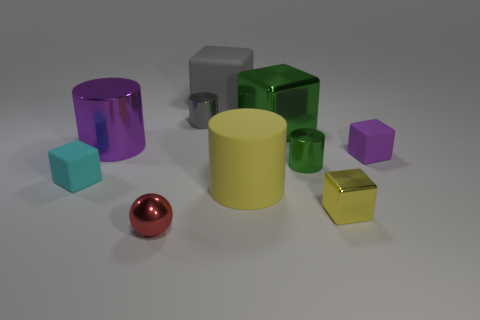There is a matte block that is the same color as the large metal cylinder; what size is it?
Ensure brevity in your answer.  Small. Is there a small purple thing made of the same material as the tiny purple cube?
Offer a terse response. No. There is a shiny thing that is left of the gray metal cylinder and behind the matte cylinder; what color is it?
Offer a very short reply. Purple. What is the material of the gray object to the left of the large matte block?
Provide a short and direct response. Metal. Are there any other metal objects that have the same shape as the big yellow object?
Offer a terse response. Yes. What number of other things are there of the same shape as the small gray metal object?
Your answer should be compact. 3. There is a red object; is it the same shape as the tiny thing that is behind the big purple cylinder?
Ensure brevity in your answer.  No. Are there any other things that have the same material as the tiny green thing?
Offer a terse response. Yes. What is the material of the tiny cyan thing that is the same shape as the purple rubber object?
Keep it short and to the point. Rubber. What number of small things are yellow matte cylinders or cyan rubber spheres?
Make the answer very short. 0. 